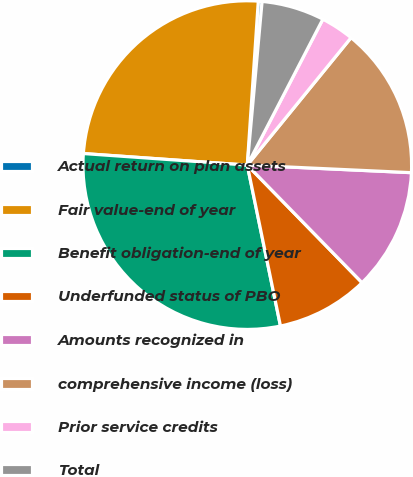Convert chart to OTSL. <chart><loc_0><loc_0><loc_500><loc_500><pie_chart><fcel>Actual return on plan assets<fcel>Fair value-end of year<fcel>Benefit obligation-end of year<fcel>Underfunded status of PBO<fcel>Amounts recognized in<fcel>comprehensive income (loss)<fcel>Prior service credits<fcel>Total<nl><fcel>0.37%<fcel>24.95%<fcel>29.36%<fcel>9.07%<fcel>11.96%<fcel>14.86%<fcel>3.27%<fcel>6.17%<nl></chart> 